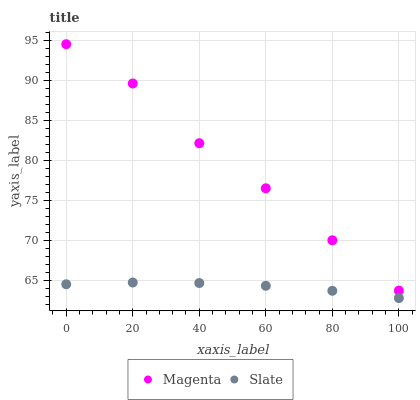Does Slate have the minimum area under the curve?
Answer yes or no. Yes. Does Magenta have the maximum area under the curve?
Answer yes or no. Yes. Does Slate have the maximum area under the curve?
Answer yes or no. No. Is Slate the smoothest?
Answer yes or no. Yes. Is Magenta the roughest?
Answer yes or no. Yes. Is Slate the roughest?
Answer yes or no. No. Does Slate have the lowest value?
Answer yes or no. Yes. Does Magenta have the highest value?
Answer yes or no. Yes. Does Slate have the highest value?
Answer yes or no. No. Is Slate less than Magenta?
Answer yes or no. Yes. Is Magenta greater than Slate?
Answer yes or no. Yes. Does Slate intersect Magenta?
Answer yes or no. No. 